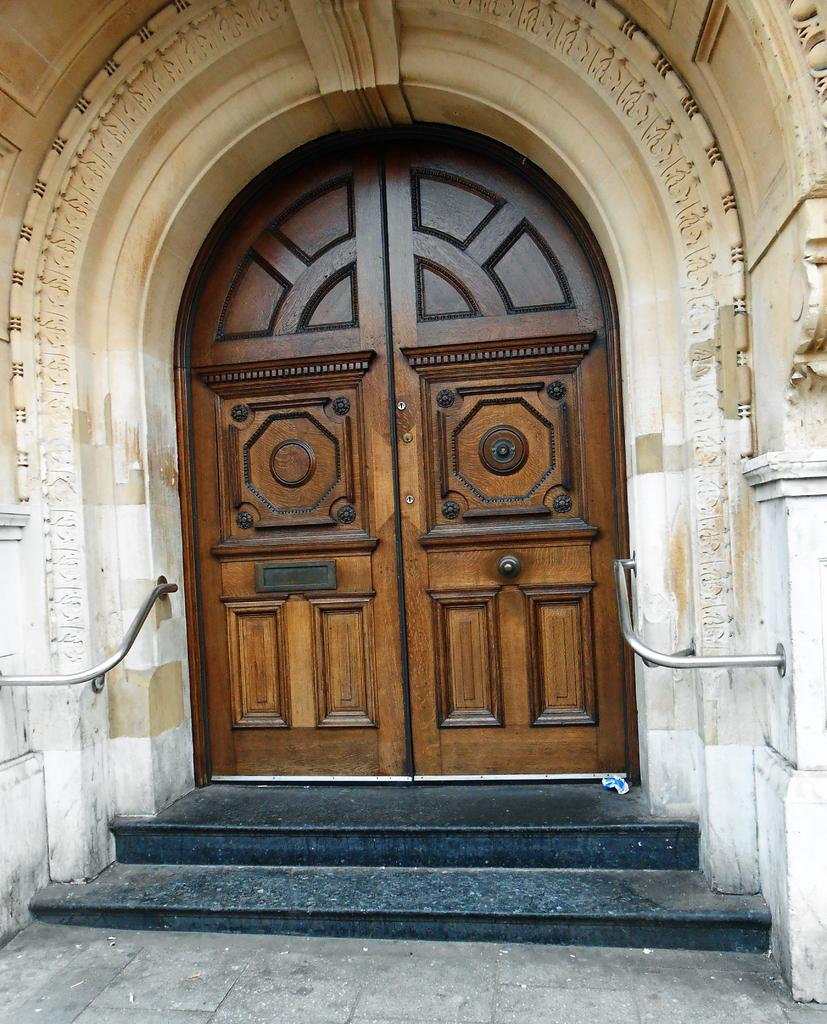What is the main architectural feature in the center of the image? There is a door in the center of the image. What safety feature is present in front of the door? There are grab bars in front of the door. What type of structure can be seen above the door? There is an arch in the image. What type of terrain is depicted in the image? There are steps in the image. What type of background is present in the image? There is a wall in the image. What type of harmony can be heard in the image? There is no audible sound in the image, so it is not possible to determine if any harmony can be heard. 